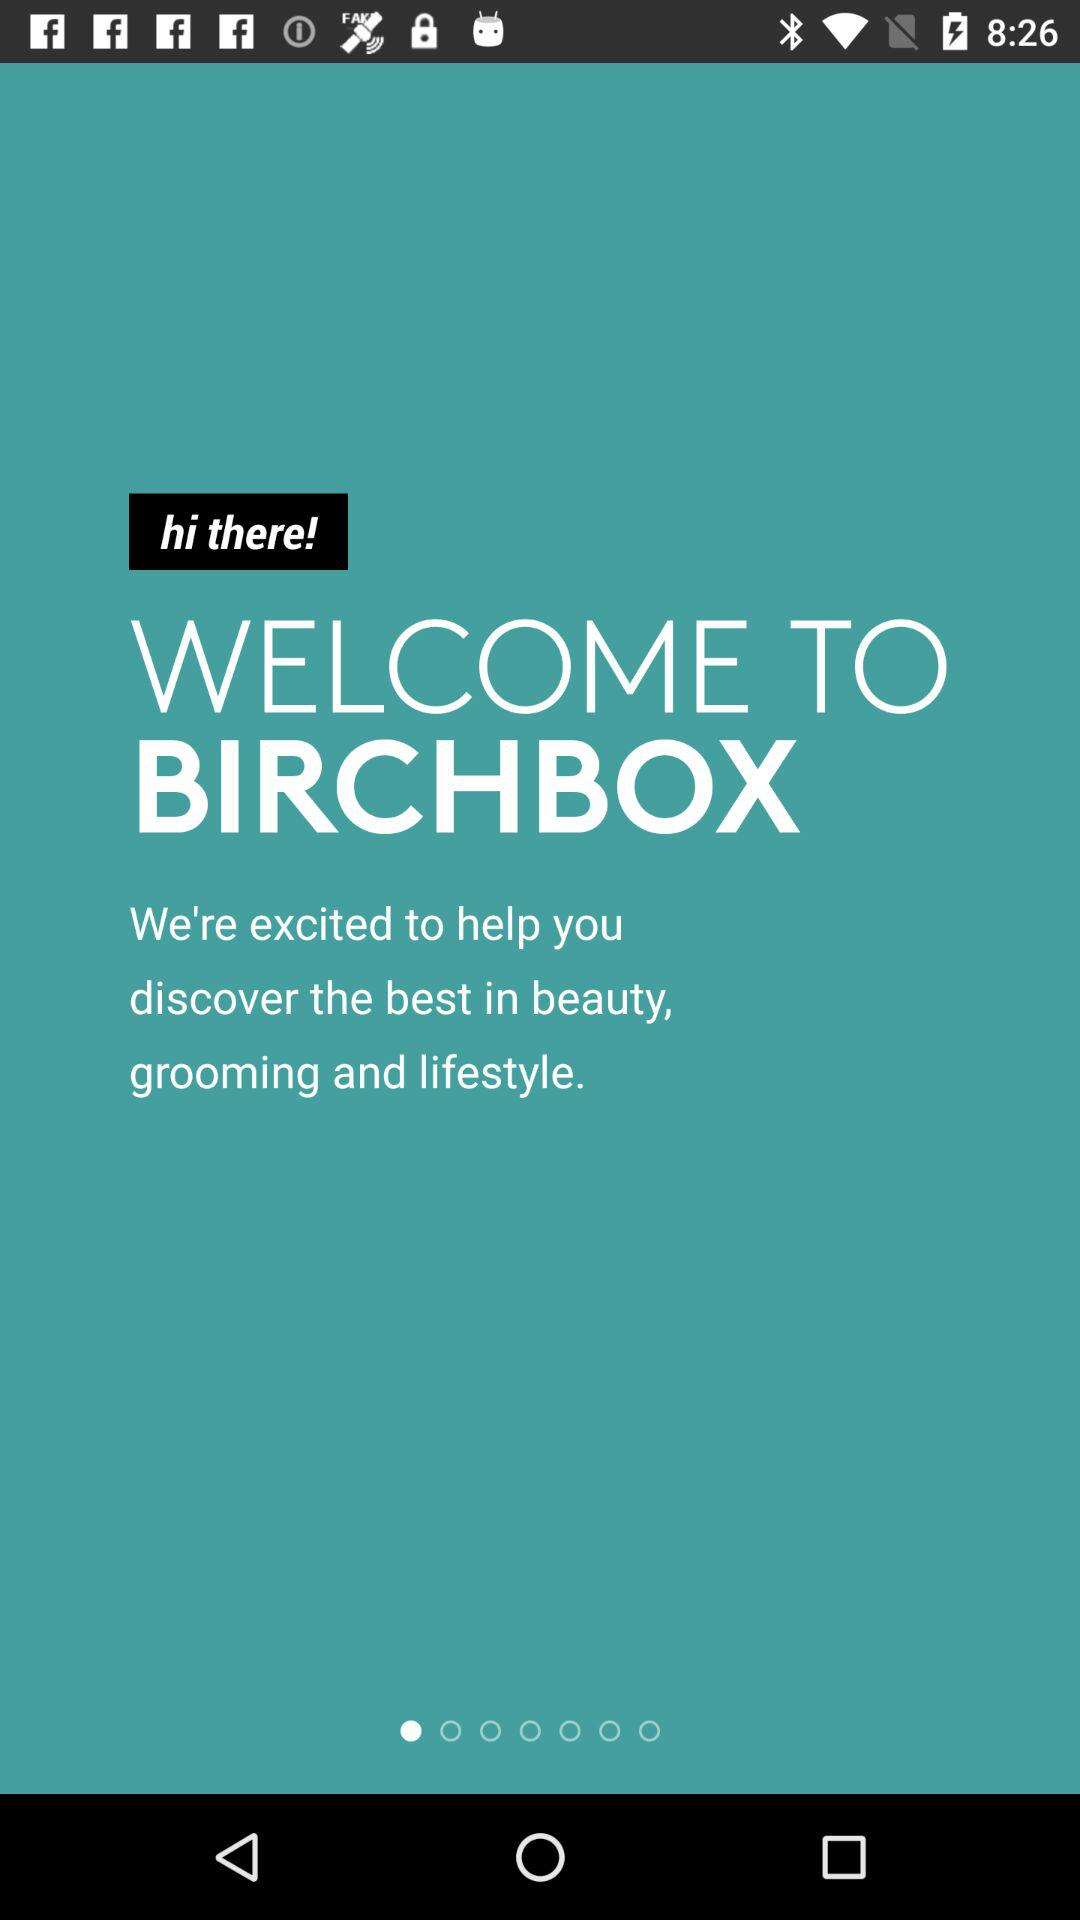Which services are provided by "BIRCHBOX"? The services provided by "BIRCHBOX" are beauty, grooming and lifestyle. 